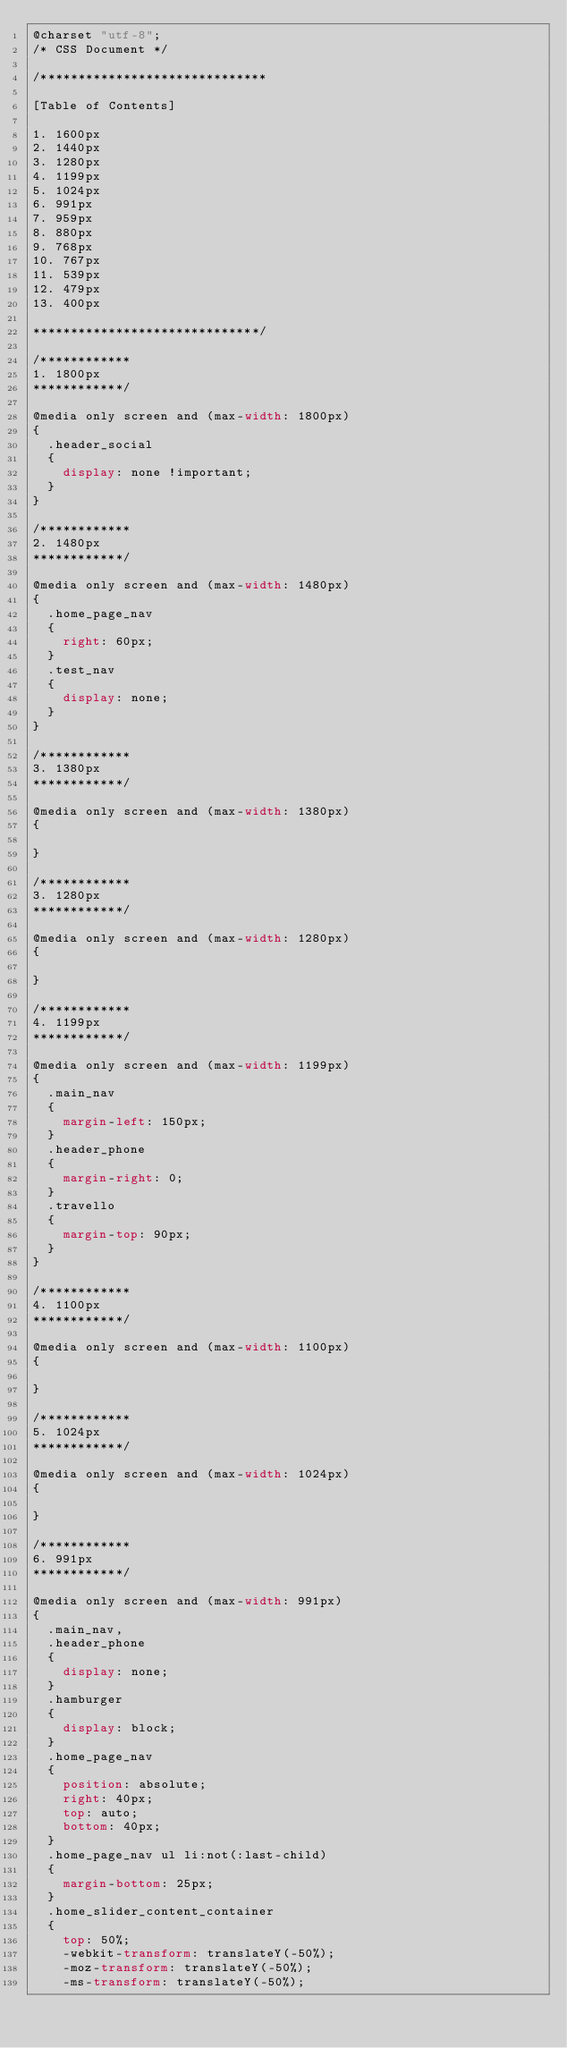<code> <loc_0><loc_0><loc_500><loc_500><_CSS_>@charset "utf-8";
/* CSS Document */

/******************************

[Table of Contents]

1. 1600px
2. 1440px
3. 1280px
4. 1199px
5. 1024px
6. 991px
7. 959px
8. 880px
9. 768px
10. 767px
11. 539px
12. 479px
13. 400px

******************************/

/************
1. 1800px
************/

@media only screen and (max-width: 1800px)
{
	.header_social
	{
		display: none !important;
	}
}

/************
2. 1480px
************/

@media only screen and (max-width: 1480px)
{
	.home_page_nav
	{
		right: 60px;
	}
	.test_nav
	{
		display: none;
	}
}

/************
3. 1380px
************/

@media only screen and (max-width: 1380px)
{

}

/************
3. 1280px
************/

@media only screen and (max-width: 1280px)
{

}

/************
4. 1199px
************/

@media only screen and (max-width: 1199px)
{
	.main_nav
	{
		margin-left: 150px;
	}
	.header_phone
	{
		margin-right: 0;
	}
	.travello
	{
		margin-top: 90px;
	}
}

/************
4. 1100px
************/

@media only screen and (max-width: 1100px)
{

}

/************
5. 1024px
************/

@media only screen and (max-width: 1024px)
{

}

/************
6. 991px
************/

@media only screen and (max-width: 991px)
{
	.main_nav,
	.header_phone
	{
		display: none;
	}
	.hamburger
	{
		display: block;
	}
	.home_page_nav
	{
		position: absolute;
		right: 40px;
		top: auto;
		bottom: 40px;
	}
	.home_page_nav ul li:not(:last-child)
	{
		margin-bottom: 25px;
	}
	.home_slider_content_container
	{
		top: 50%;
		-webkit-transform: translateY(-50%);
		-moz-transform: translateY(-50%);
		-ms-transform: translateY(-50%);</code> 